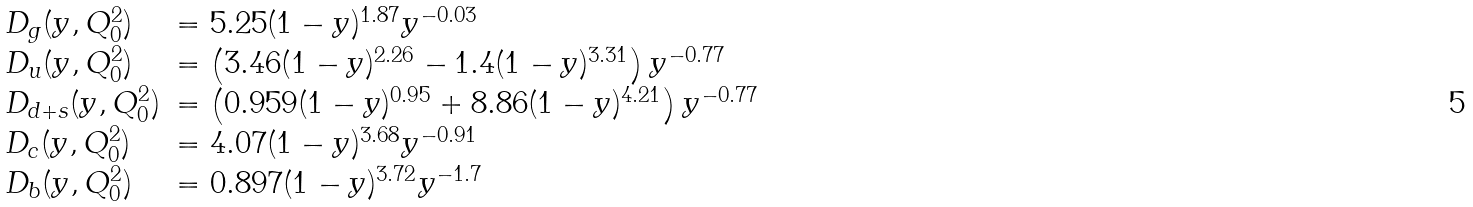<formula> <loc_0><loc_0><loc_500><loc_500>\begin{array} { l l } D _ { g } ( y , Q _ { 0 } ^ { 2 } ) & = 5 . 2 5 ( 1 - y ) ^ { 1 . 8 7 } y ^ { - 0 . 0 3 } \\ D _ { u } ( y , Q _ { 0 } ^ { 2 } ) & = \left ( 3 . 4 6 ( 1 - y ) ^ { 2 . 2 6 } - 1 . 4 ( 1 - y ) ^ { 3 . 3 1 } \right ) y ^ { - 0 . 7 7 } \\ D _ { d + s } ( y , Q _ { 0 } ^ { 2 } ) & = \left ( 0 . 9 5 9 ( 1 - y ) ^ { 0 . 9 5 } + 8 . 8 6 ( 1 - y ) ^ { 4 . 2 1 } \right ) y ^ { - 0 . 7 7 } \\ D _ { c } ( y , Q _ { 0 } ^ { 2 } ) & = 4 . 0 7 ( 1 - y ) ^ { 3 . 6 8 } y ^ { - 0 . 9 1 } \\ D _ { b } ( y , Q _ { 0 } ^ { 2 } ) & = 0 . 8 9 7 ( 1 - y ) ^ { 3 . 7 2 } y ^ { - 1 . 7 } \\ \end{array}</formula> 